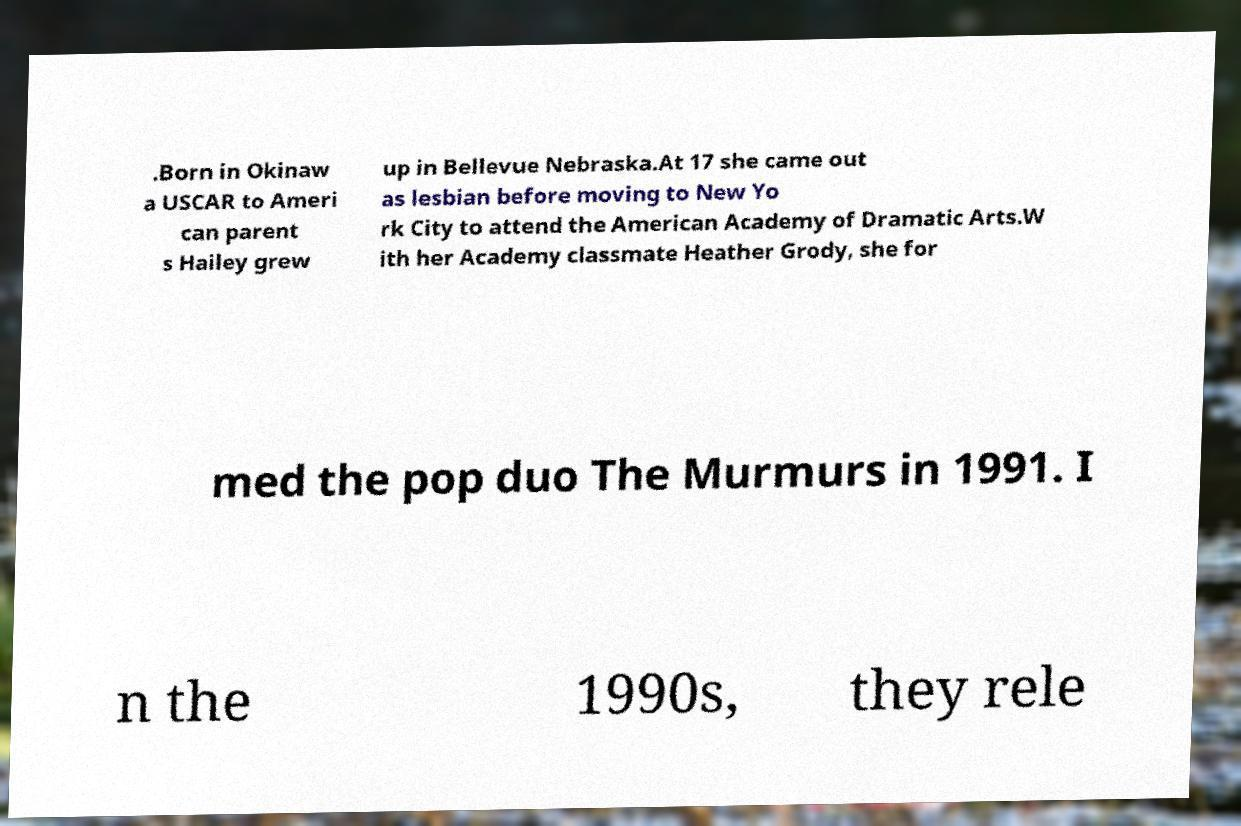Could you assist in decoding the text presented in this image and type it out clearly? .Born in Okinaw a USCAR to Ameri can parent s Hailey grew up in Bellevue Nebraska.At 17 she came out as lesbian before moving to New Yo rk City to attend the American Academy of Dramatic Arts.W ith her Academy classmate Heather Grody, she for med the pop duo The Murmurs in 1991. I n the 1990s, they rele 